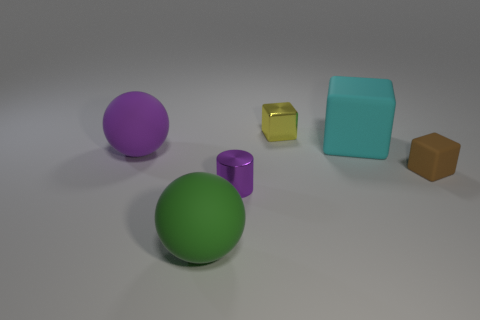There is a small thing that is in front of the big block and left of the brown cube; what shape is it?
Offer a terse response. Cylinder. Are there any cyan rubber things that have the same shape as the large green rubber object?
Ensure brevity in your answer.  No. The brown object that is the same size as the purple metal cylinder is what shape?
Give a very brief answer. Cube. What material is the small purple cylinder?
Your answer should be compact. Metal. What is the size of the metal thing that is behind the large matte object right of the large object in front of the purple sphere?
Provide a short and direct response. Small. What is the material of the sphere that is the same color as the tiny metallic cylinder?
Provide a succinct answer. Rubber. What number of rubber objects are big green cubes or small yellow things?
Ensure brevity in your answer.  0. How big is the green matte object?
Provide a succinct answer. Large. How many things are yellow objects or big spheres to the right of the purple matte ball?
Provide a succinct answer. 2. How many other objects are there of the same color as the cylinder?
Ensure brevity in your answer.  1. 